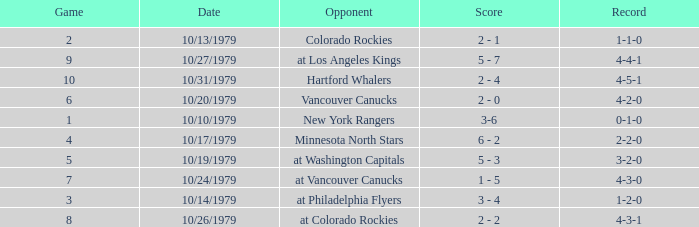What is the score for the opponent Vancouver Canucks? 2 - 0. 